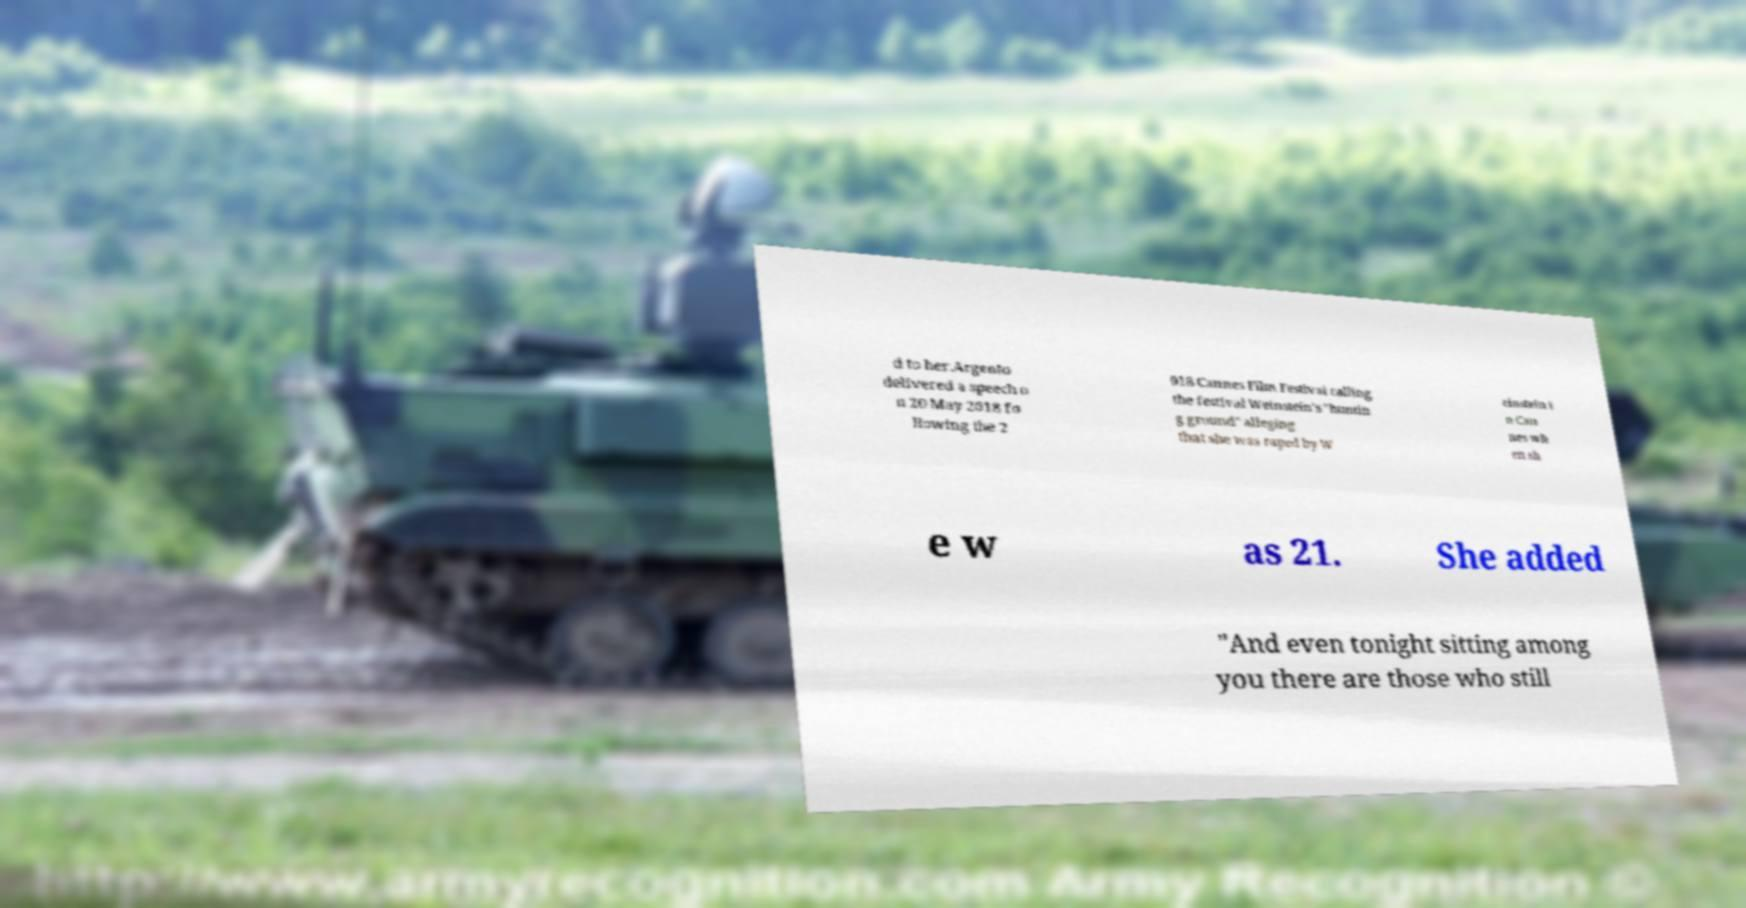Please read and relay the text visible in this image. What does it say? d to her.Argento delivered a speech o n 20 May 2018 fo llowing the 2 018 Cannes Film Festival calling the festival Weinstein's "huntin g ground" alleging that she was raped by W einstein i n Can nes wh en sh e w as 21. She added "And even tonight sitting among you there are those who still 